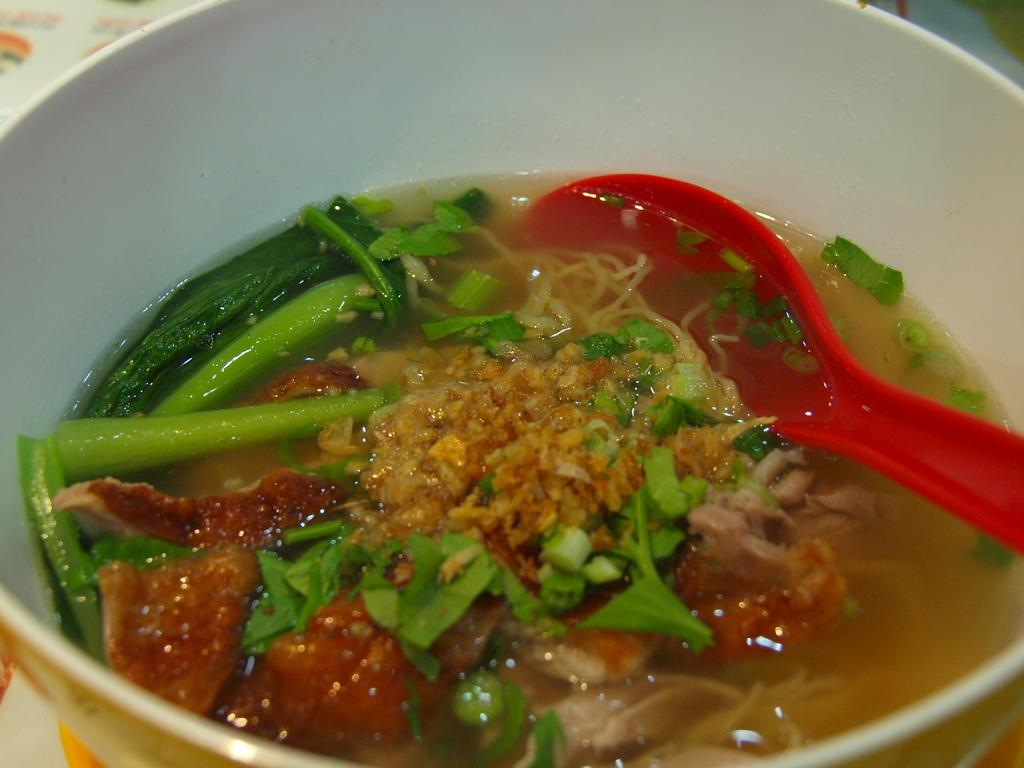What is the main piece of furniture in the image? There is a table in the image. What is placed on the table? There is a bowl on the table. What is the color of the spoon in the bowl? The spoon in the bowl is red. What is the consistency of the food item in the bowl? The food item in the bowl has some liquid. Can you see any waves or sand in the image? No, there are no waves or sand present in the image. The image features a table, a bowl, a red spoon, and a food item with some liquid. 